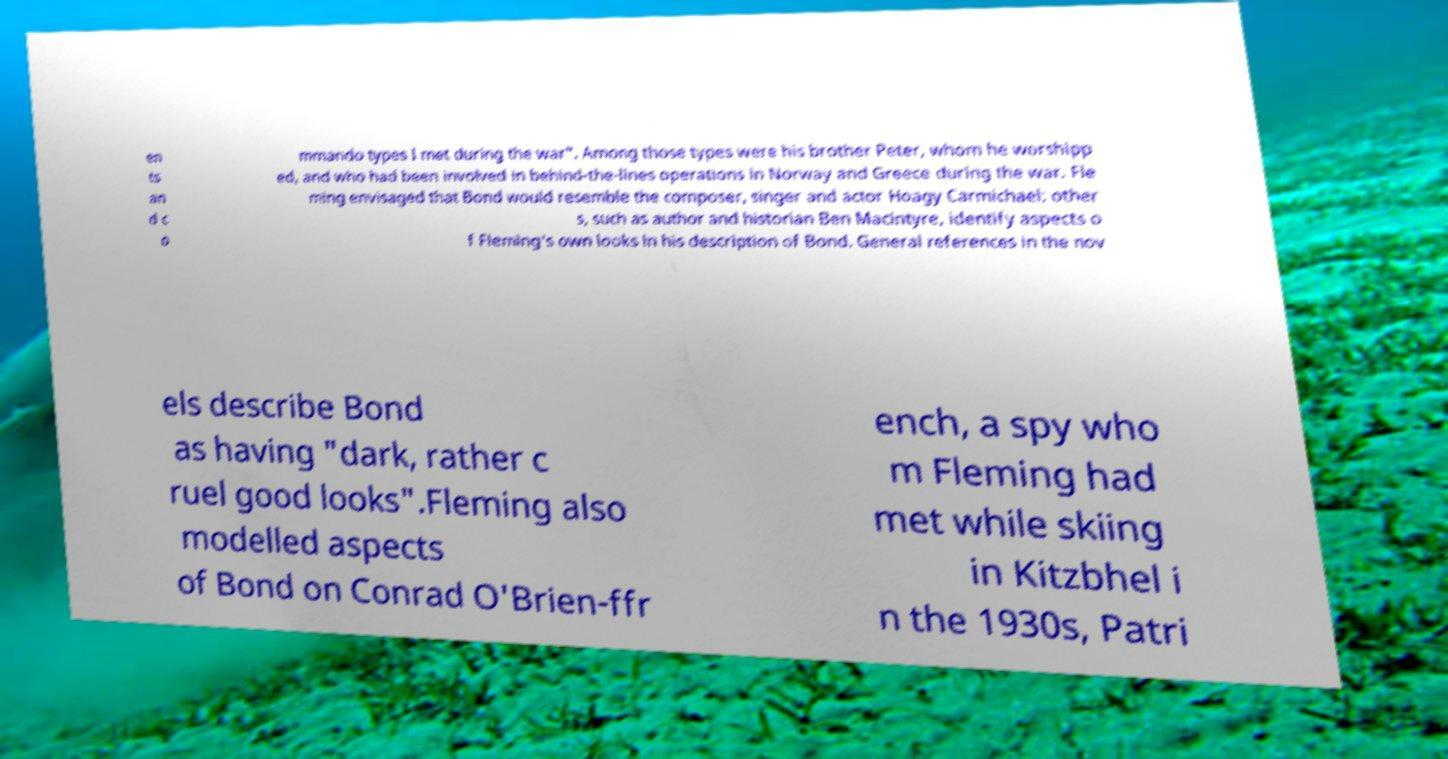Please identify and transcribe the text found in this image. en ts an d c o mmando types I met during the war". Among those types were his brother Peter, whom he worshipp ed, and who had been involved in behind-the-lines operations in Norway and Greece during the war. Fle ming envisaged that Bond would resemble the composer, singer and actor Hoagy Carmichael; other s, such as author and historian Ben Macintyre, identify aspects o f Fleming's own looks in his description of Bond. General references in the nov els describe Bond as having "dark, rather c ruel good looks".Fleming also modelled aspects of Bond on Conrad O'Brien-ffr ench, a spy who m Fleming had met while skiing in Kitzbhel i n the 1930s, Patri 